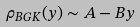<formula> <loc_0><loc_0><loc_500><loc_500>\rho _ { B G K } ( y ) \sim A - B y</formula> 